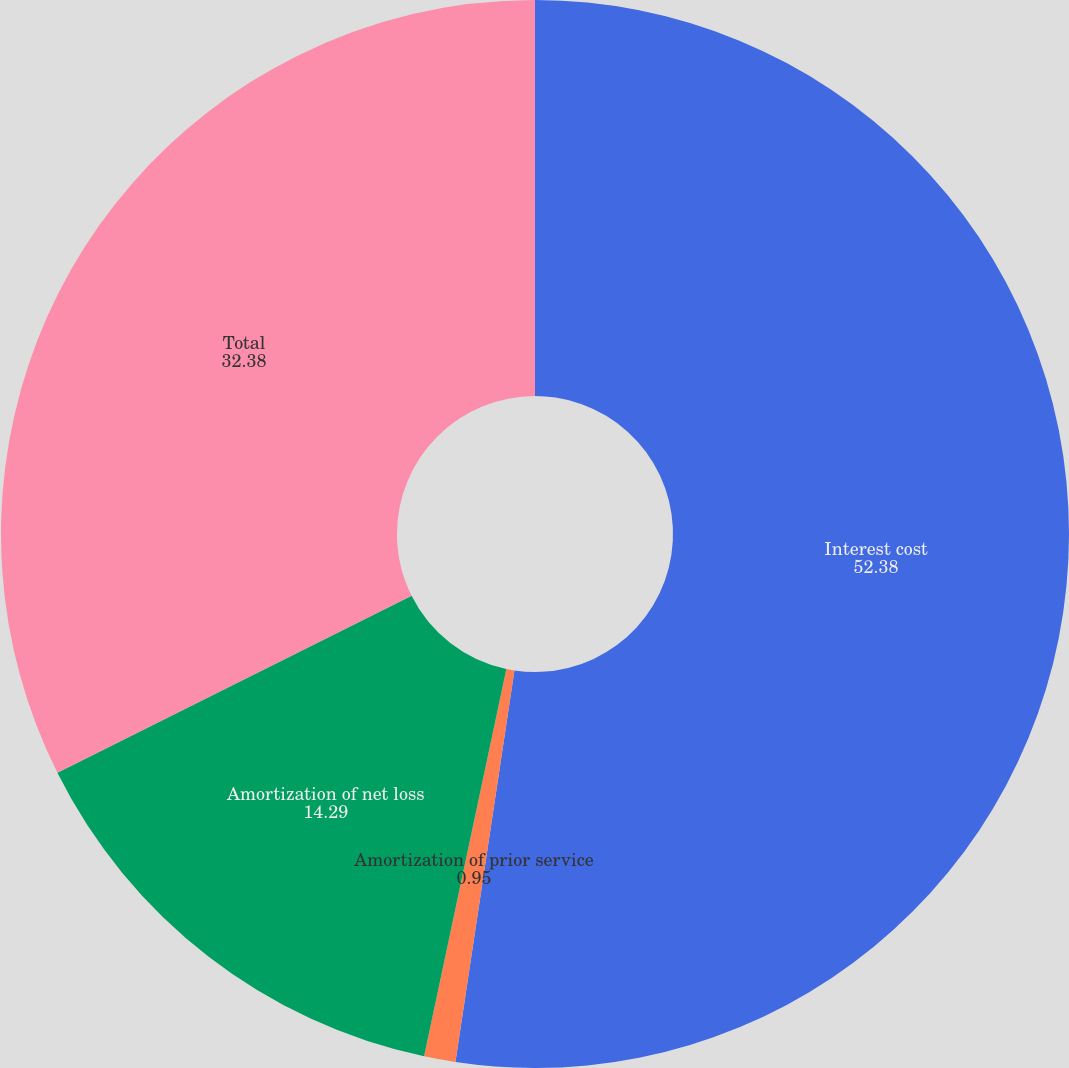<chart> <loc_0><loc_0><loc_500><loc_500><pie_chart><fcel>Interest cost<fcel>Amortization of prior service<fcel>Amortization of net loss<fcel>Total<nl><fcel>52.38%<fcel>0.95%<fcel>14.29%<fcel>32.38%<nl></chart> 